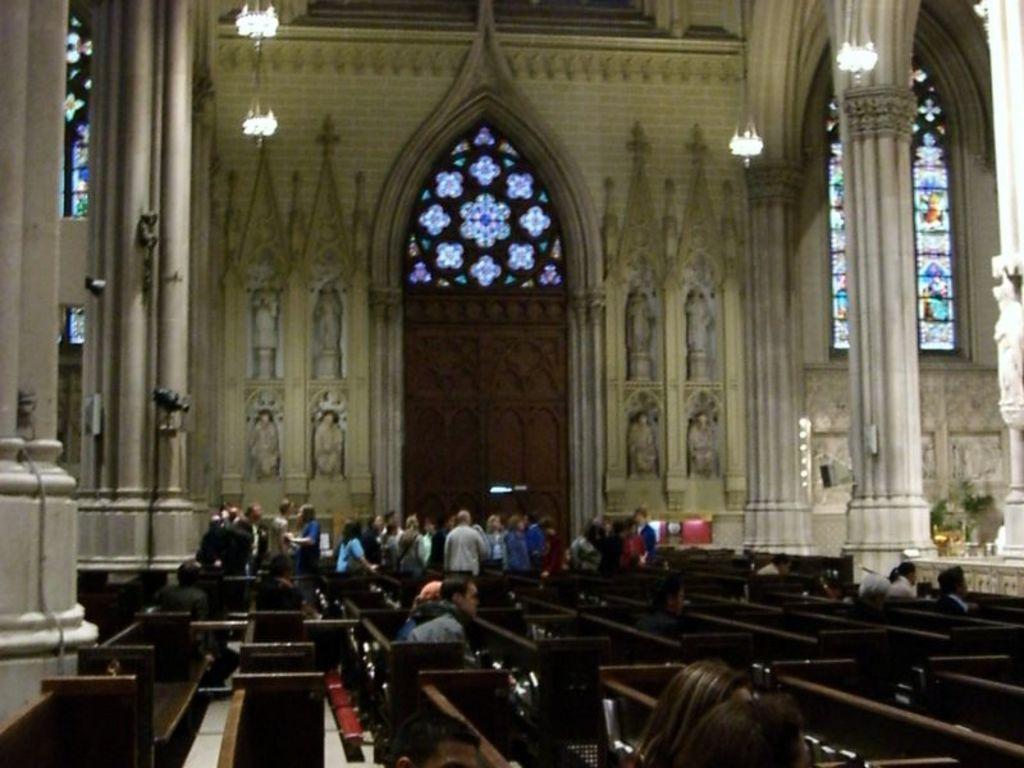In one or two sentences, can you explain what this image depicts? In the foreground I can see benches and a group of people are standing on the floor. In the background, I can see a building walls, pillars, windows and chandeliers. This image is taken, maybe in a church. 